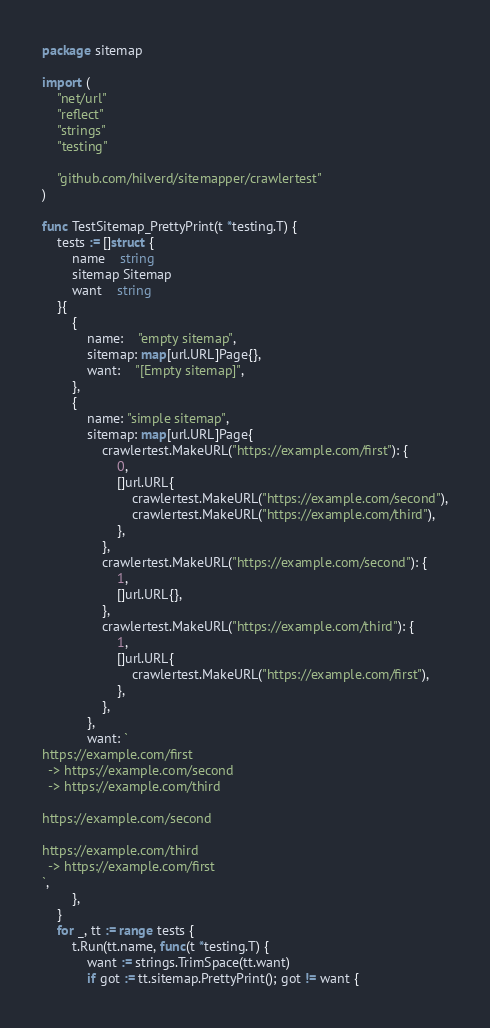<code> <loc_0><loc_0><loc_500><loc_500><_Go_>package sitemap

import (
	"net/url"
	"reflect"
	"strings"
	"testing"

	"github.com/hilverd/sitemapper/crawlertest"
)

func TestSitemap_PrettyPrint(t *testing.T) {
	tests := []struct {
		name    string
		sitemap Sitemap
		want    string
	}{
		{
			name:    "empty sitemap",
			sitemap: map[url.URL]Page{},
			want:    "[Empty sitemap]",
		},
		{
			name: "simple sitemap",
			sitemap: map[url.URL]Page{
				crawlertest.MakeURL("https://example.com/first"): {
					0,
					[]url.URL{
						crawlertest.MakeURL("https://example.com/second"),
						crawlertest.MakeURL("https://example.com/third"),
					},
				},
				crawlertest.MakeURL("https://example.com/second"): {
					1,
					[]url.URL{},
				},
				crawlertest.MakeURL("https://example.com/third"): {
					1,
					[]url.URL{
						crawlertest.MakeURL("https://example.com/first"),
					},
				},
			},
			want: `
https://example.com/first
  -> https://example.com/second
  -> https://example.com/third

https://example.com/second

https://example.com/third
  -> https://example.com/first
`,
		},
	}
	for _, tt := range tests {
		t.Run(tt.name, func(t *testing.T) {
			want := strings.TrimSpace(tt.want)
			if got := tt.sitemap.PrettyPrint(); got != want {</code> 